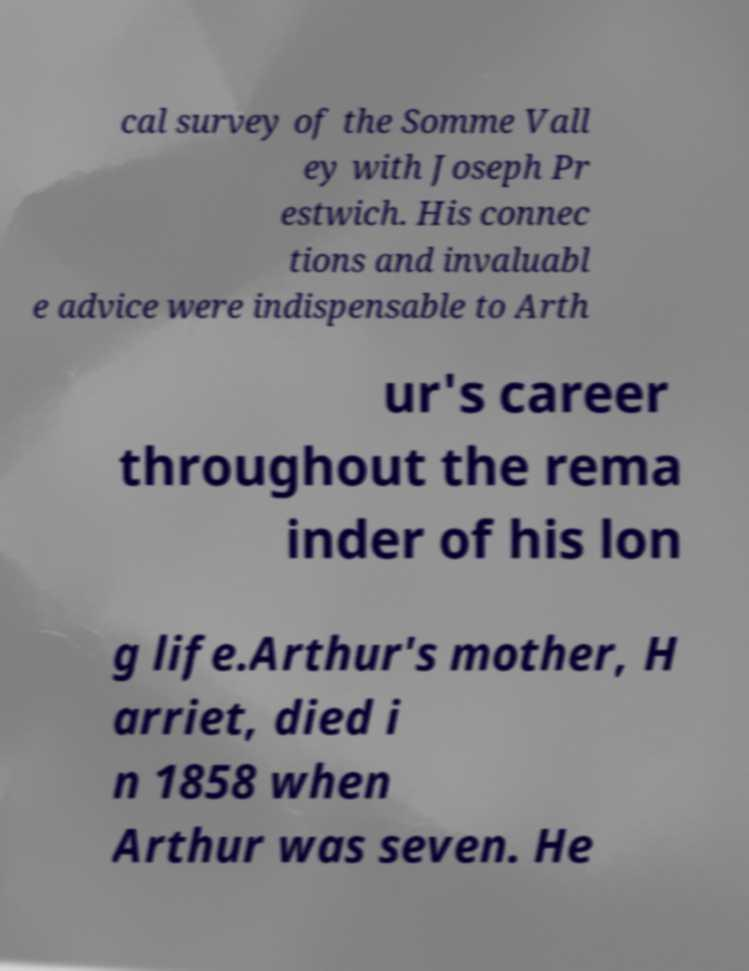I need the written content from this picture converted into text. Can you do that? cal survey of the Somme Vall ey with Joseph Pr estwich. His connec tions and invaluabl e advice were indispensable to Arth ur's career throughout the rema inder of his lon g life.Arthur's mother, H arriet, died i n 1858 when Arthur was seven. He 